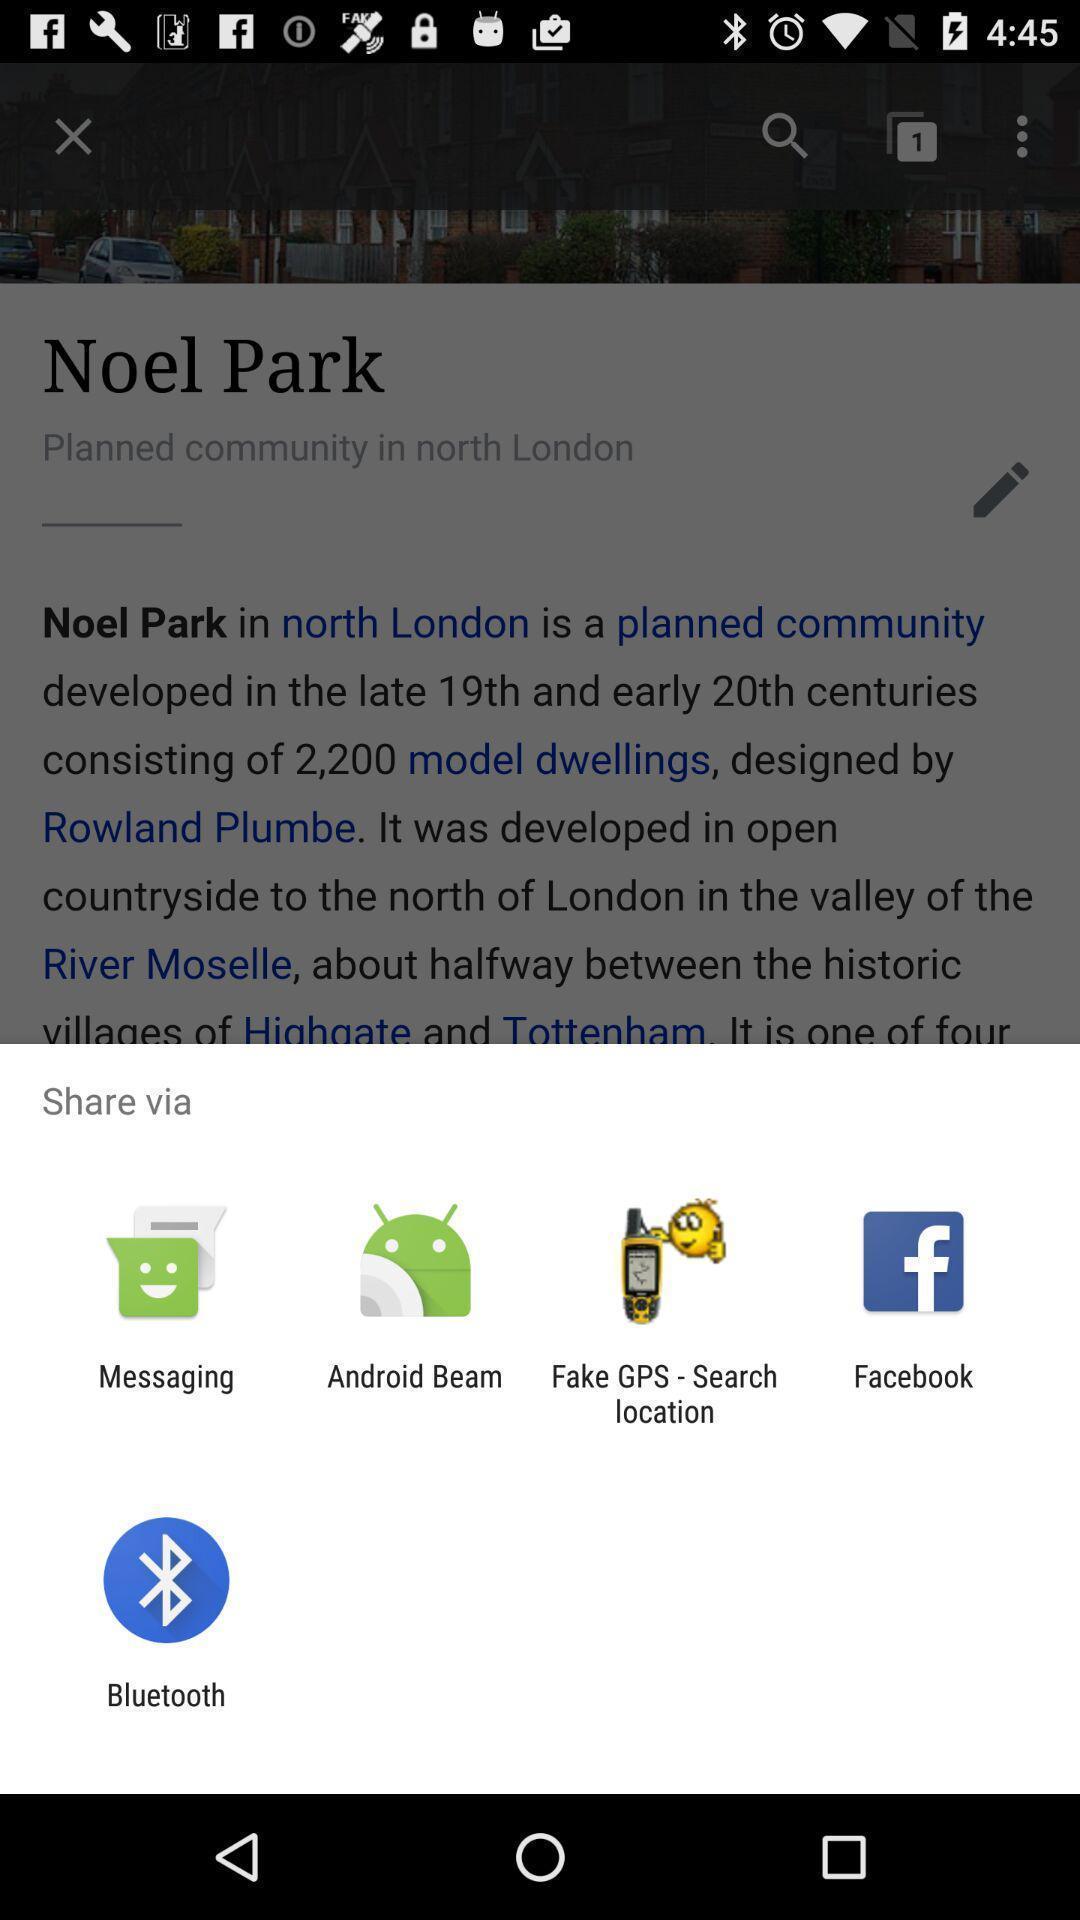What is the overall content of this screenshot? Pop-up showing various sharing options. 